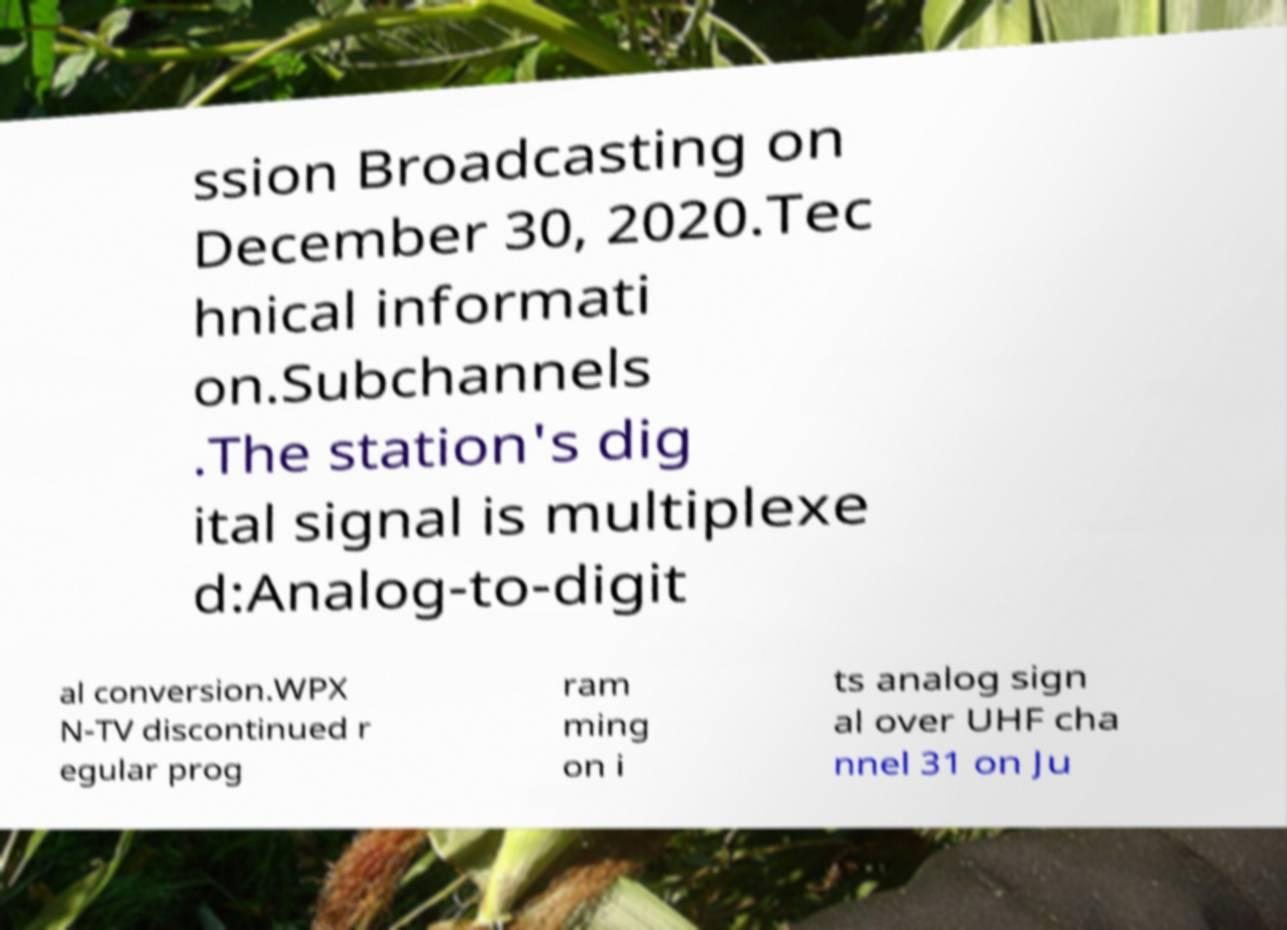There's text embedded in this image that I need extracted. Can you transcribe it verbatim? ssion Broadcasting on December 30, 2020.Tec hnical informati on.Subchannels .The station's dig ital signal is multiplexe d:Analog-to-digit al conversion.WPX N-TV discontinued r egular prog ram ming on i ts analog sign al over UHF cha nnel 31 on Ju 